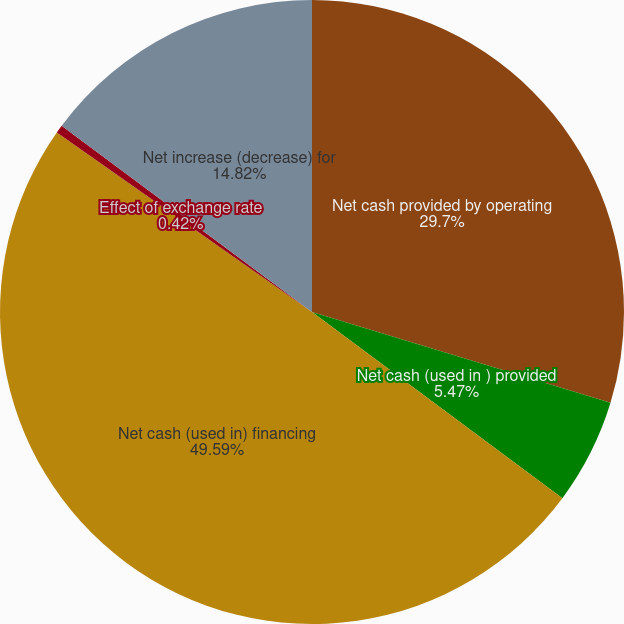<chart> <loc_0><loc_0><loc_500><loc_500><pie_chart><fcel>Net cash provided by operating<fcel>Net cash (used in ) provided<fcel>Net cash (used in) financing<fcel>Effect of exchange rate<fcel>Net increase (decrease) for<nl><fcel>29.7%<fcel>5.47%<fcel>49.58%<fcel>0.42%<fcel>14.82%<nl></chart> 